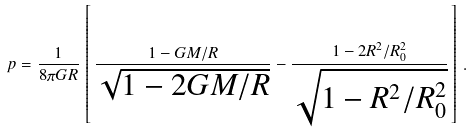<formula> <loc_0><loc_0><loc_500><loc_500>p = \frac { 1 } { 8 \pi G R } \, \left [ \, \frac { 1 - G M / R } { \sqrt { 1 - 2 G M / R } } - \frac { 1 - 2 R ^ { 2 } / R _ { 0 } ^ { 2 } } { \sqrt { 1 - R ^ { 2 } / R _ { 0 } ^ { 2 } } } \, \right ] \, .</formula> 